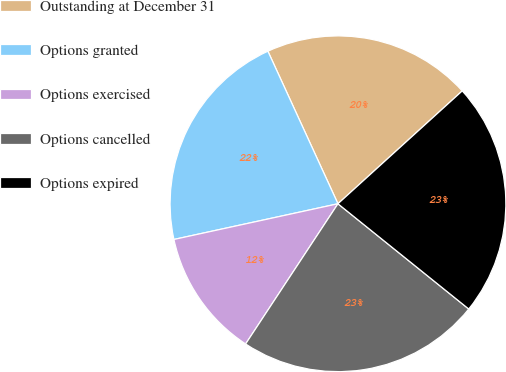Convert chart to OTSL. <chart><loc_0><loc_0><loc_500><loc_500><pie_chart><fcel>Outstanding at December 31<fcel>Options granted<fcel>Options exercised<fcel>Options cancelled<fcel>Options expired<nl><fcel>20.12%<fcel>21.56%<fcel>12.32%<fcel>23.49%<fcel>22.52%<nl></chart> 